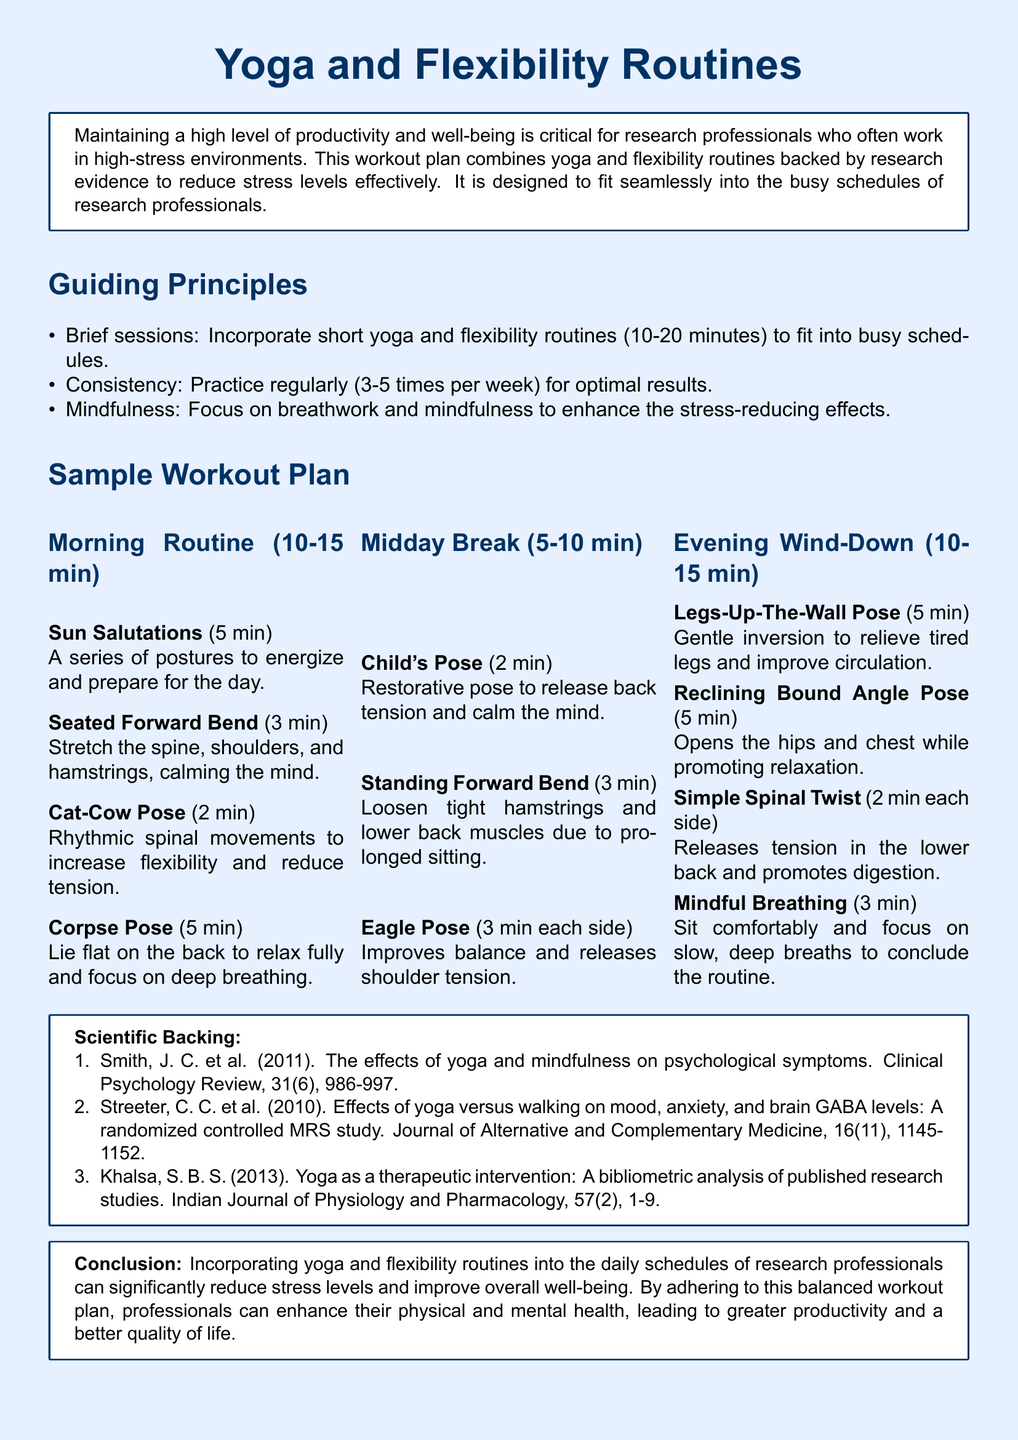What is the main focus of the workout plan? The document states that the workout plan focuses on combining yoga and flexibility routines to reduce stress levels effectively for research professionals.
Answer: Combining yoga and flexibility routines How long should each yoga session be? The document recommends that yoga sessions last between 10 to 20 minutes to fit into busy schedules.
Answer: 10-20 minutes How many times per week should one practice? The plan suggests practicing regularly between 3 to 5 times per week for optimal results.
Answer: 3-5 times What is the duration of the Sun Salutations activity? The Sun Salutations activity is specified to take 5 minutes in the morning routine section.
Answer: 5 minutes Which pose in the midday break helps release back tension? The Child's Pose is highlighted as a restorative pose that releases back tension.
Answer: Child's Pose What pose is recommended for relieving tired legs in the evening? Legs-Up-The-Wall Pose is suggested for relieving tired legs and improving circulation during the evening routine.
Answer: Legs-Up-The-Wall Pose Who is primarily targeted by this workout plan? The document indicates that research professionals are the main target group for this workout plan.
Answer: Research professionals What key principle emphasizes focusing on breathing? The key principle of Mindfulness emphasizes focusing on breathwork to enhance stress-reducing effects.
Answer: Mindfulness 